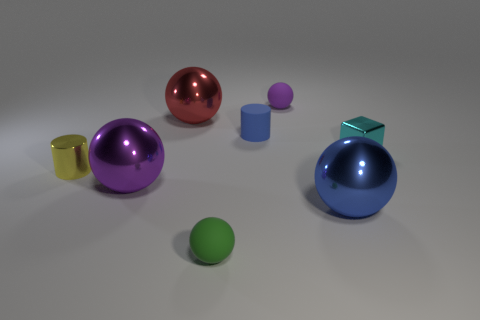The big red thing that is the same material as the tiny cyan cube is what shape?
Keep it short and to the point. Sphere. Is the number of cylinders that are on the left side of the green object greater than the number of gray metallic cylinders?
Give a very brief answer. Yes. How many tiny balls are the same color as the tiny metallic cylinder?
Ensure brevity in your answer.  0. How many other objects are the same color as the small matte cylinder?
Give a very brief answer. 1. Is the number of blue metal cylinders greater than the number of cubes?
Ensure brevity in your answer.  No. What material is the tiny blue cylinder?
Provide a succinct answer. Rubber. Do the purple sphere that is in front of the cyan thing and the big red sphere have the same size?
Offer a very short reply. Yes. There is a purple object in front of the cyan cube; what size is it?
Give a very brief answer. Large. How many big brown things are there?
Your response must be concise. 0. There is a object that is both on the right side of the purple rubber ball and behind the big purple metallic object; what is its color?
Offer a terse response. Cyan. 